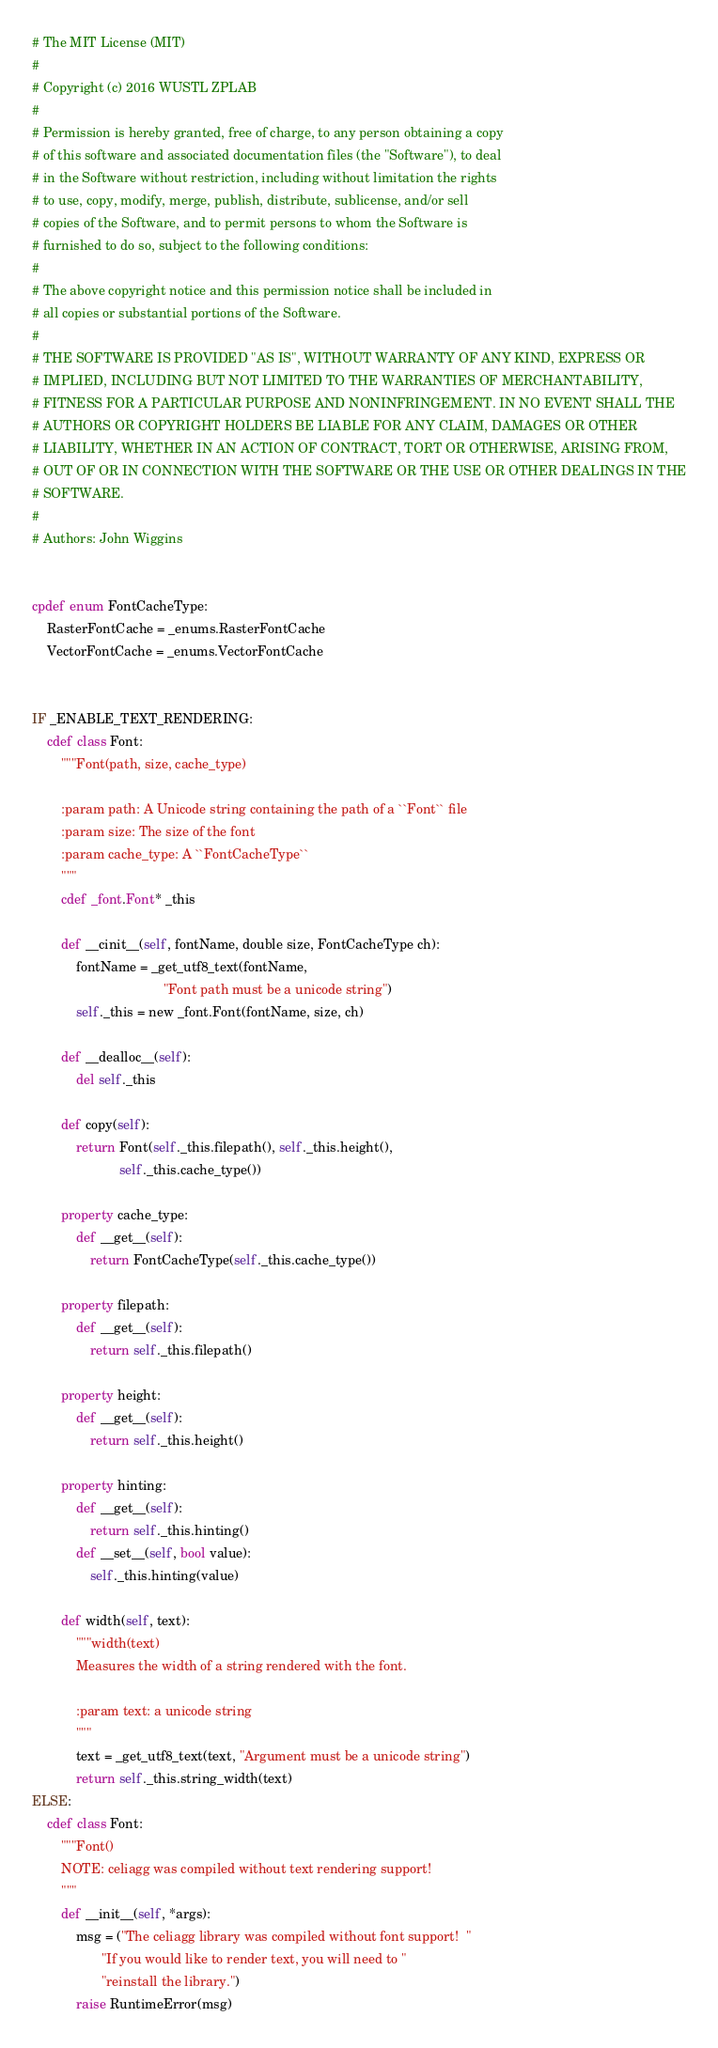Convert code to text. <code><loc_0><loc_0><loc_500><loc_500><_Cython_># The MIT License (MIT)
#
# Copyright (c) 2016 WUSTL ZPLAB
#
# Permission is hereby granted, free of charge, to any person obtaining a copy
# of this software and associated documentation files (the "Software"), to deal
# in the Software without restriction, including without limitation the rights
# to use, copy, modify, merge, publish, distribute, sublicense, and/or sell
# copies of the Software, and to permit persons to whom the Software is
# furnished to do so, subject to the following conditions:
#
# The above copyright notice and this permission notice shall be included in
# all copies or substantial portions of the Software.
#
# THE SOFTWARE IS PROVIDED "AS IS", WITHOUT WARRANTY OF ANY KIND, EXPRESS OR
# IMPLIED, INCLUDING BUT NOT LIMITED TO THE WARRANTIES OF MERCHANTABILITY,
# FITNESS FOR A PARTICULAR PURPOSE AND NONINFRINGEMENT. IN NO EVENT SHALL THE
# AUTHORS OR COPYRIGHT HOLDERS BE LIABLE FOR ANY CLAIM, DAMAGES OR OTHER
# LIABILITY, WHETHER IN AN ACTION OF CONTRACT, TORT OR OTHERWISE, ARISING FROM,
# OUT OF OR IN CONNECTION WITH THE SOFTWARE OR THE USE OR OTHER DEALINGS IN THE
# SOFTWARE.
#
# Authors: John Wiggins


cpdef enum FontCacheType:
    RasterFontCache = _enums.RasterFontCache
    VectorFontCache = _enums.VectorFontCache 


IF _ENABLE_TEXT_RENDERING:
    cdef class Font:
        """Font(path, size, cache_type)

        :param path: A Unicode string containing the path of a ``Font`` file
        :param size: The size of the font
        :param cache_type: A ``FontCacheType``
        """
        cdef _font.Font* _this

        def __cinit__(self, fontName, double size, FontCacheType ch):
            fontName = _get_utf8_text(fontName,
                                    "Font path must be a unicode string")
            self._this = new _font.Font(fontName, size, ch)

        def __dealloc__(self):
            del self._this

        def copy(self):
            return Font(self._this.filepath(), self._this.height(),
                        self._this.cache_type())

        property cache_type:
            def __get__(self):
                return FontCacheType(self._this.cache_type())

        property filepath:
            def __get__(self):
                return self._this.filepath()

        property height:
            def __get__(self):
                return self._this.height()

        property hinting:
            def __get__(self):
                return self._this.hinting()
            def __set__(self, bool value):
                self._this.hinting(value)

        def width(self, text):
            """width(text)
            Measures the width of a string rendered with the font.

            :param text: a unicode string
            """
            text = _get_utf8_text(text, "Argument must be a unicode string")
            return self._this.string_width(text)
ELSE:
    cdef class Font:
        """Font()
        NOTE: celiagg was compiled without text rendering support!
        """
        def __init__(self, *args):
            msg = ("The celiagg library was compiled without font support!  "
                   "If you would like to render text, you will need to "
                   "reinstall the library.")
            raise RuntimeError(msg)
</code> 